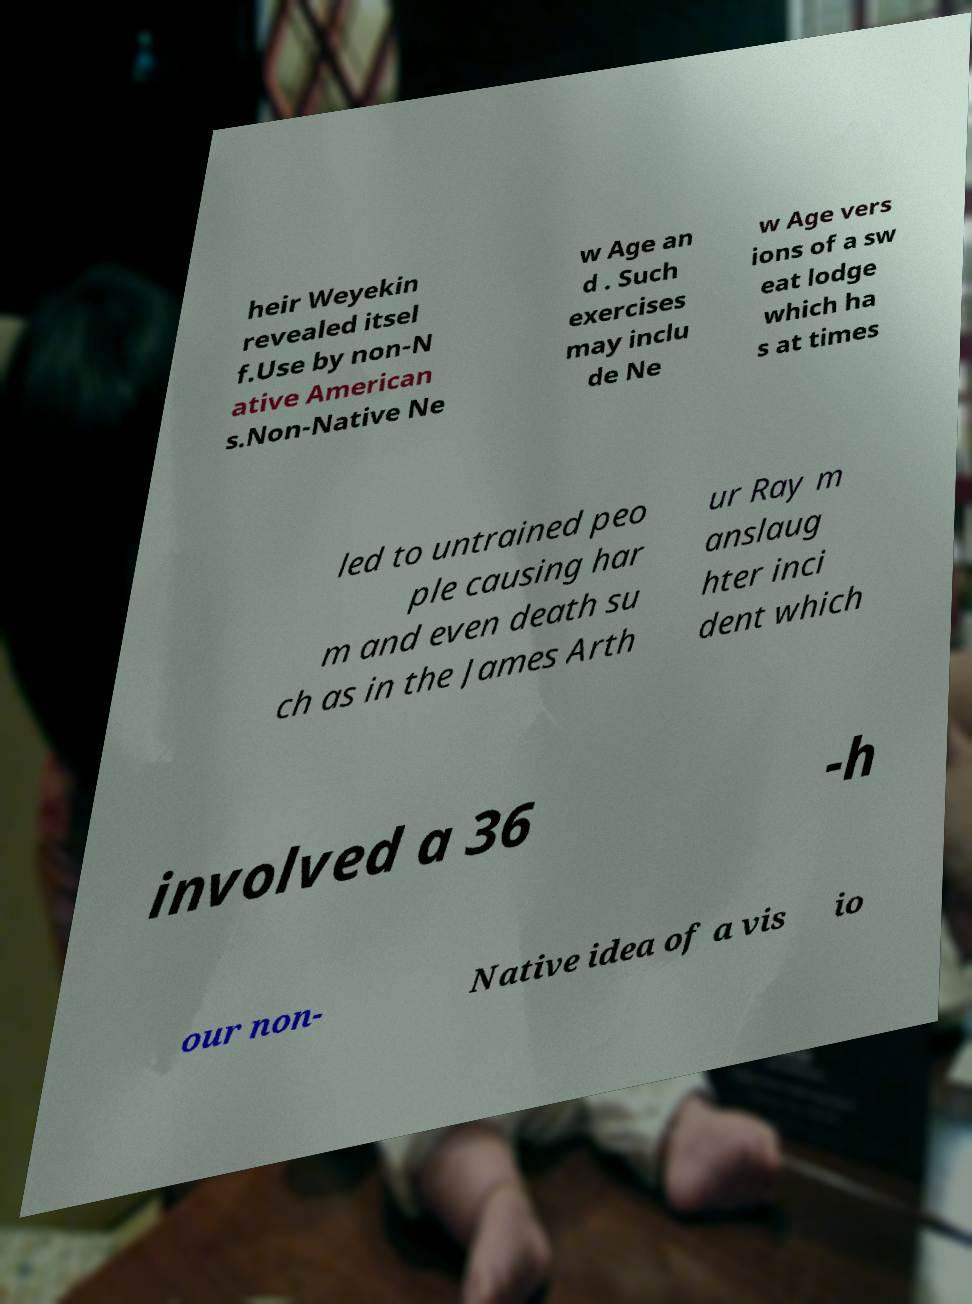Please identify and transcribe the text found in this image. heir Weyekin revealed itsel f.Use by non-N ative American s.Non-Native Ne w Age an d . Such exercises may inclu de Ne w Age vers ions of a sw eat lodge which ha s at times led to untrained peo ple causing har m and even death su ch as in the James Arth ur Ray m anslaug hter inci dent which involved a 36 -h our non- Native idea of a vis io 